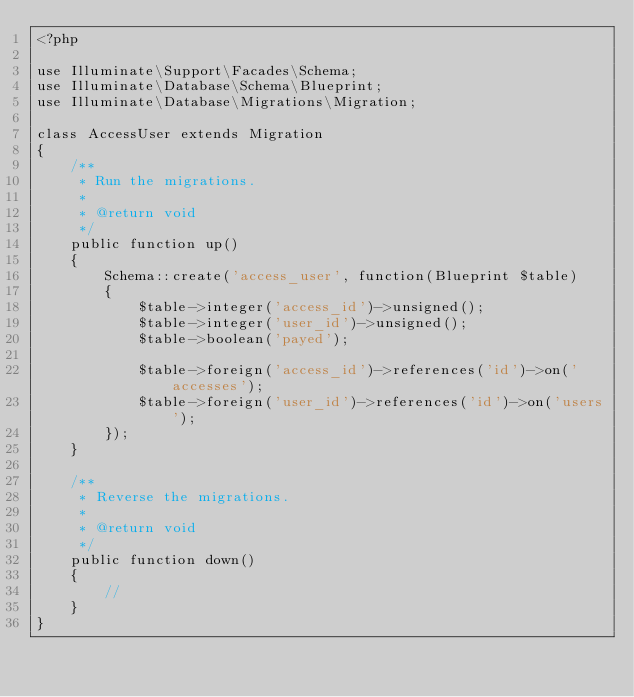Convert code to text. <code><loc_0><loc_0><loc_500><loc_500><_PHP_><?php

use Illuminate\Support\Facades\Schema;
use Illuminate\Database\Schema\Blueprint;
use Illuminate\Database\Migrations\Migration;

class AccessUser extends Migration
{
    /**
     * Run the migrations.
     *
     * @return void
     */
    public function up()
    {
        Schema::create('access_user', function(Blueprint $table)
        {
            $table->integer('access_id')->unsigned();
            $table->integer('user_id')->unsigned();
            $table->boolean('payed');

            $table->foreign('access_id')->references('id')->on('accesses');
            $table->foreign('user_id')->references('id')->on('users');
        });
    }

    /**
     * Reverse the migrations.
     *
     * @return void
     */
    public function down()
    {
        //
    }
}
</code> 